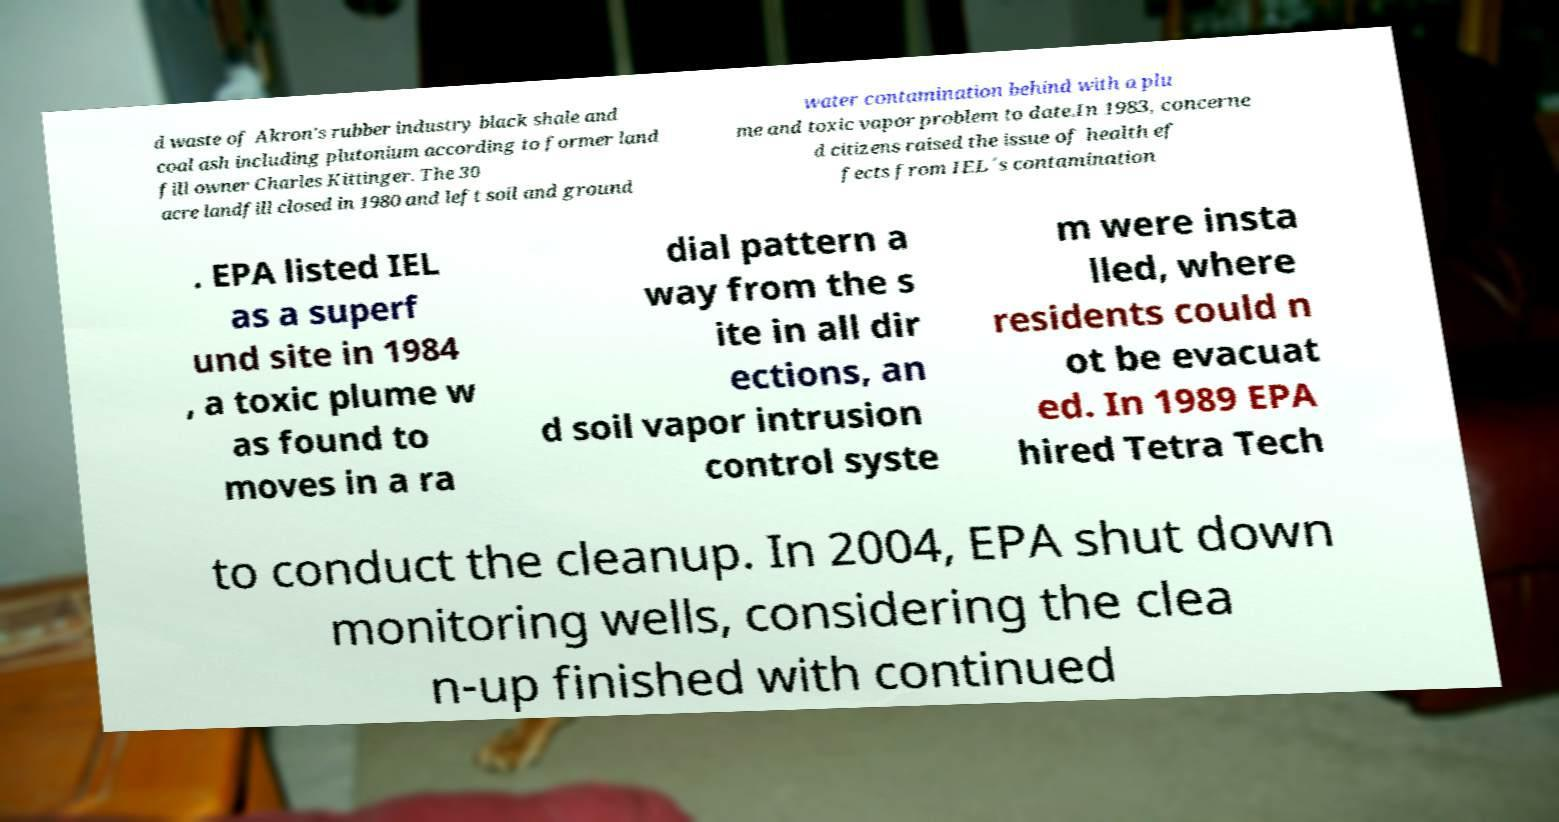I need the written content from this picture converted into text. Can you do that? d waste of Akron's rubber industry black shale and coal ash including plutonium according to former land fill owner Charles Kittinger. The 30 acre landfill closed in 1980 and left soil and ground water contamination behind with a plu me and toxic vapor problem to date.In 1983, concerne d citizens raised the issue of health ef fects from IEL´s contamination . EPA listed IEL as a superf und site in 1984 , a toxic plume w as found to moves in a ra dial pattern a way from the s ite in all dir ections, an d soil vapor intrusion control syste m were insta lled, where residents could n ot be evacuat ed. In 1989 EPA hired Tetra Tech to conduct the cleanup. In 2004, EPA shut down monitoring wells, considering the clea n-up finished with continued 